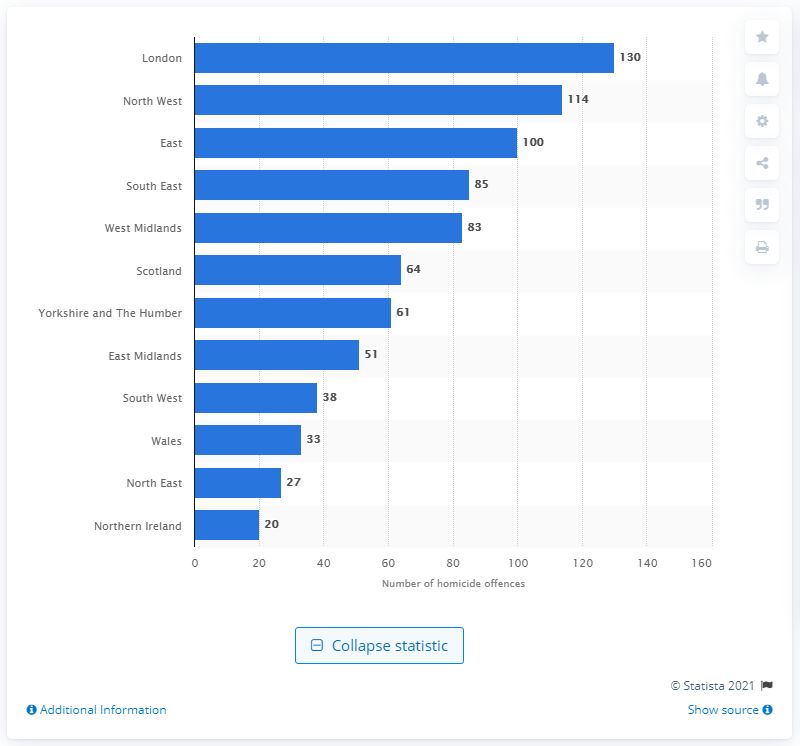Give some essential details in this illustration. In the 2019/2020 fiscal year, there were 114 homicides reported in North West England. There were 130 homicide offenses in London in the 2019/2020 fiscal year. 